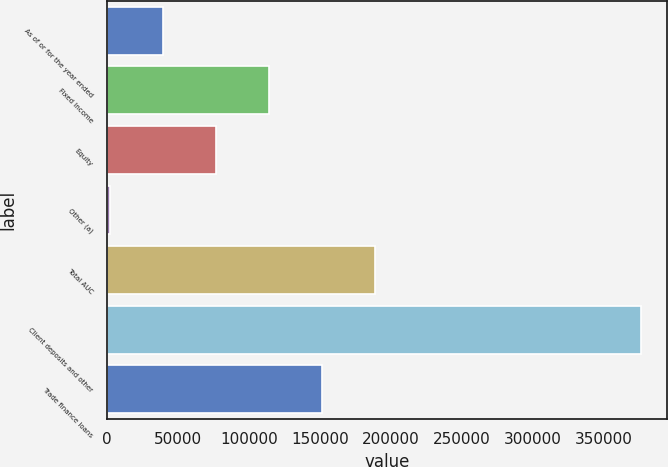Convert chart. <chart><loc_0><loc_0><loc_500><loc_500><bar_chart><fcel>As of or for the year ended<fcel>Fixed Income<fcel>Equity<fcel>Other (a)<fcel>Total AUC<fcel>Client deposits and other<fcel>Trade finance loans<nl><fcel>39362.1<fcel>114234<fcel>76798.2<fcel>1926<fcel>189106<fcel>376287<fcel>151670<nl></chart> 